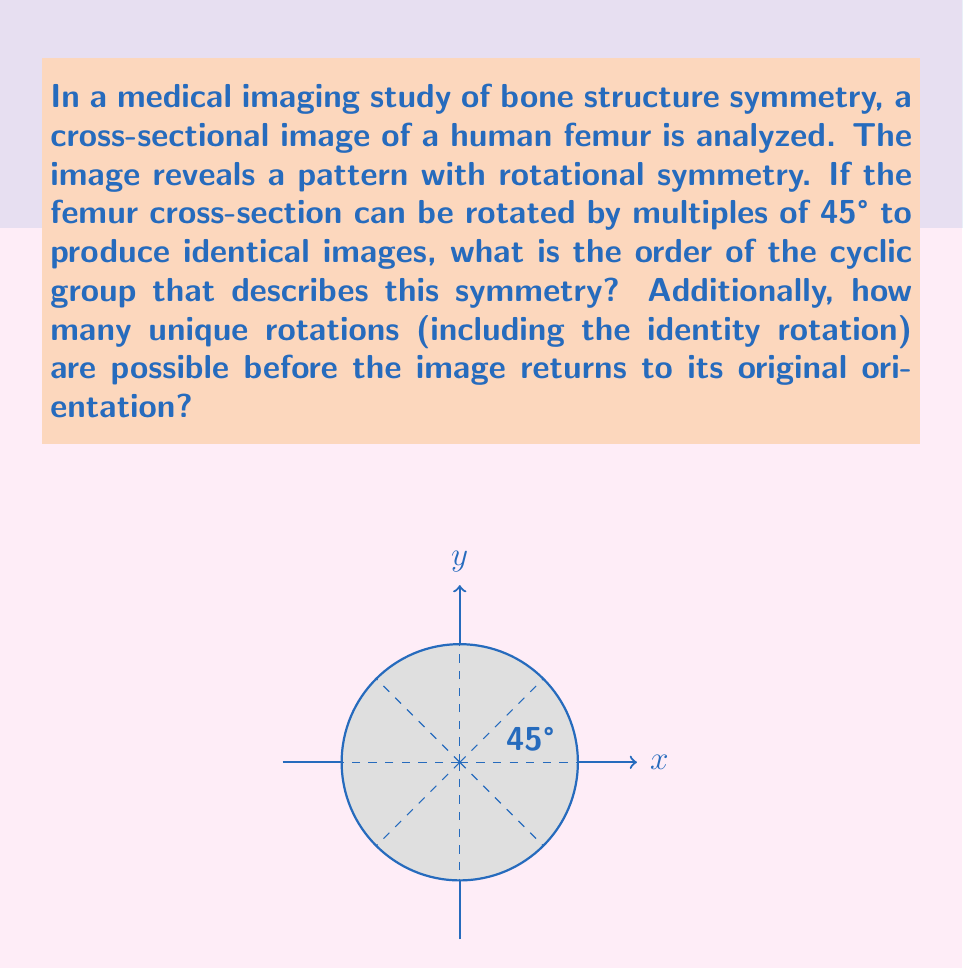Help me with this question. To solve this problem, let's break it down step-by-step:

1) First, we need to understand what the order of a cyclic group means in the context of rotational symmetry. The order of the group is the number of elements in the group, which in this case corresponds to the number of distinct rotations that bring the image back to an identical orientation.

2) We're told that the femur cross-section can be rotated by multiples of 45° to produce identical images. Let's calculate how many rotations are needed to complete a full 360° rotation:

   $$\frac{360°}{45°} = 8$$

3) This means that after 8 rotations of 45°, we return to the original orientation. These 8 rotations include:
   0° (identity), 45°, 90°, 135°, 180°, 225°, 270°, 315°

4) In group theory, we denote this cyclic group as $C_8$ or $\mathbb{Z}_8$, where the subscript 8 indicates the order of the group.

5) The order of the cyclic group is therefore 8.

6) As for the number of unique rotations, it's the same as the order of the group. Each rotation by 45° produces a unique orientation until we complete a full 360° rotation.

Therefore, the order of the cyclic group is 8, and there are 8 unique rotations (including the identity rotation) before the image returns to its original orientation.
Answer: Order of cyclic group: 8; Number of unique rotations: 8 